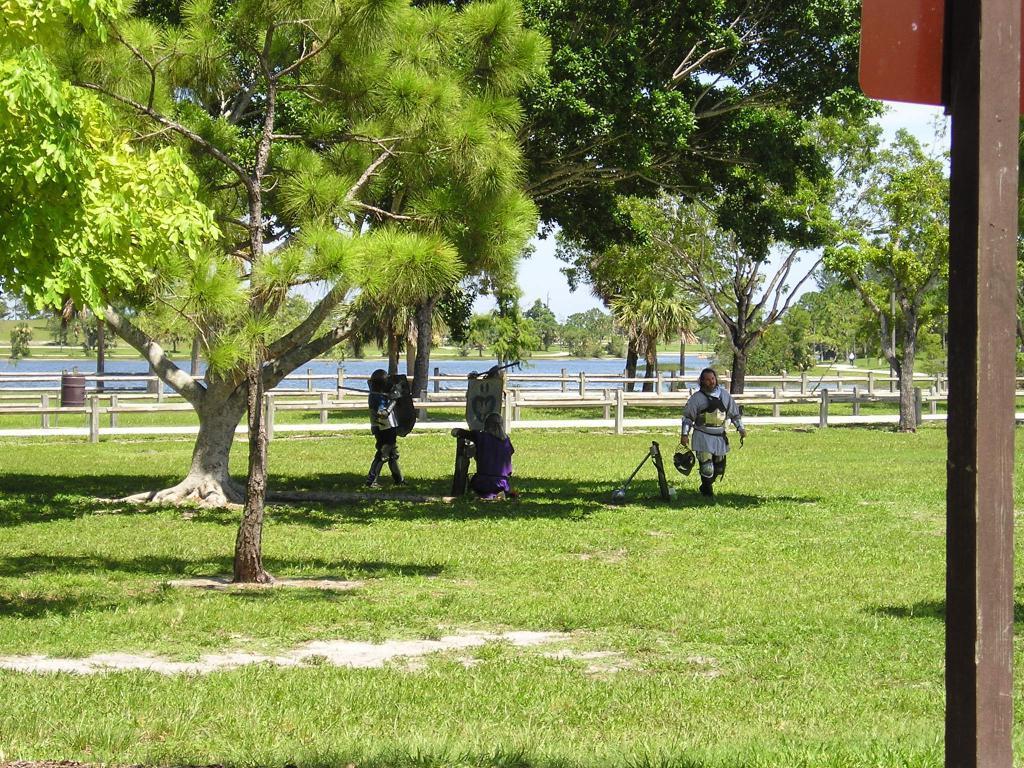Can you describe this image briefly? This picture is taken from the outside of the city and it is sunny. In this image, on the right side, we can see a wood pole. In the middle of the image, we can see three people are walking on the grass. On the left side, we can see some trees. In the background, we can see some trees, plants, water in a lake. At the top, we can see a sky which is a bit cloudy, at the bottom, we can see a grass. 